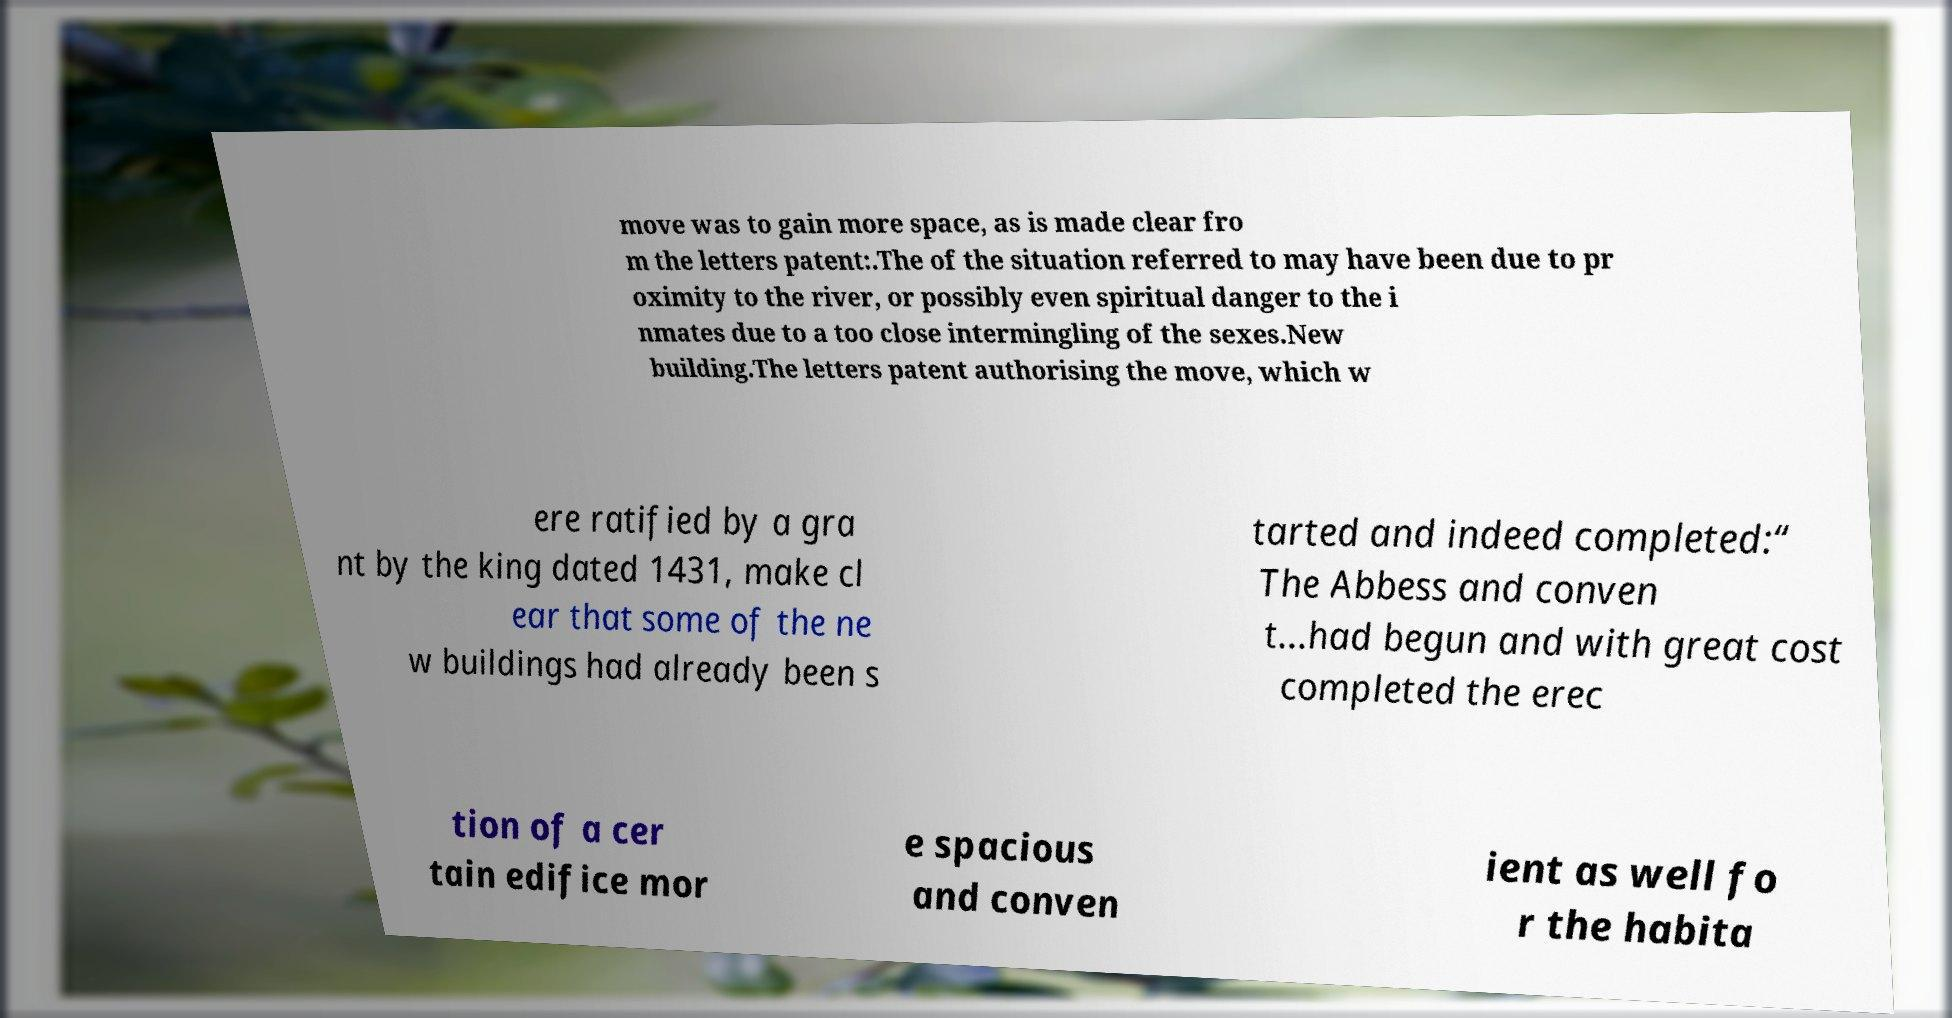Please identify and transcribe the text found in this image. move was to gain more space, as is made clear fro m the letters patent:.The of the situation referred to may have been due to pr oximity to the river, or possibly even spiritual danger to the i nmates due to a too close intermingling of the sexes.New building.The letters patent authorising the move, which w ere ratified by a gra nt by the king dated 1431, make cl ear that some of the ne w buildings had already been s tarted and indeed completed:“ The Abbess and conven t...had begun and with great cost completed the erec tion of a cer tain edifice mor e spacious and conven ient as well fo r the habita 